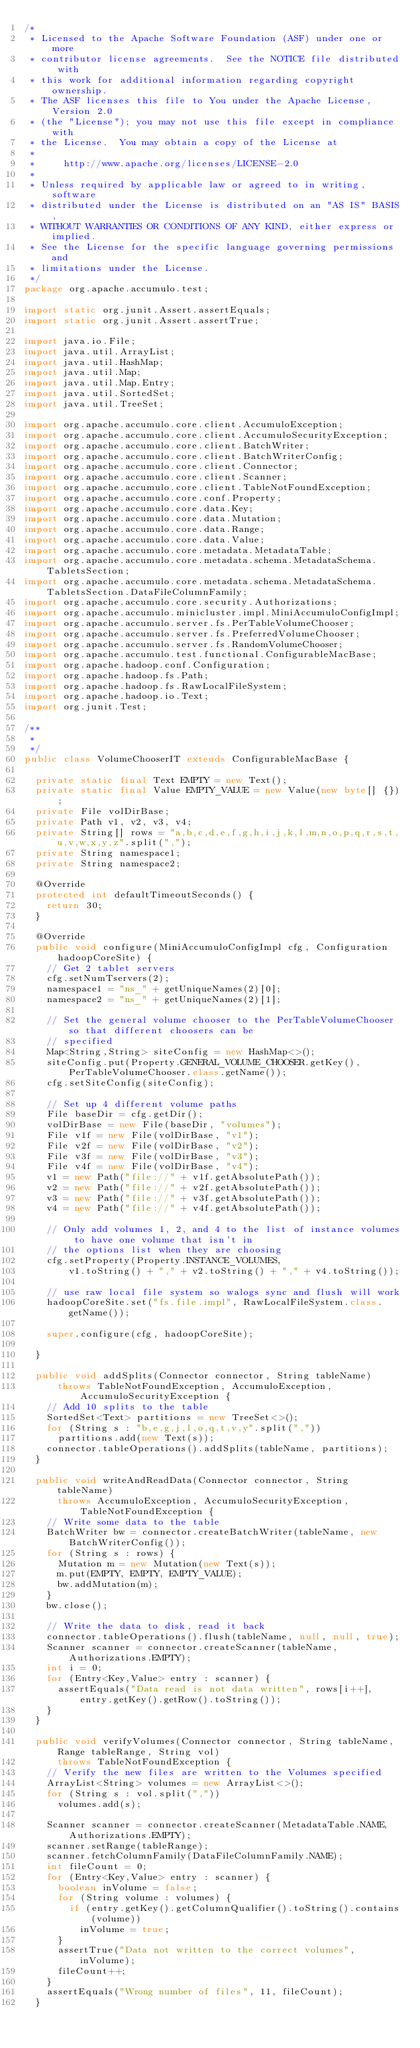<code> <loc_0><loc_0><loc_500><loc_500><_Java_>/*
 * Licensed to the Apache Software Foundation (ASF) under one or more
 * contributor license agreements.  See the NOTICE file distributed with
 * this work for additional information regarding copyright ownership.
 * The ASF licenses this file to You under the Apache License, Version 2.0
 * (the "License"); you may not use this file except in compliance with
 * the License.  You may obtain a copy of the License at
 *
 *     http://www.apache.org/licenses/LICENSE-2.0
 *
 * Unless required by applicable law or agreed to in writing, software
 * distributed under the License is distributed on an "AS IS" BASIS,
 * WITHOUT WARRANTIES OR CONDITIONS OF ANY KIND, either express or implied.
 * See the License for the specific language governing permissions and
 * limitations under the License.
 */
package org.apache.accumulo.test;

import static org.junit.Assert.assertEquals;
import static org.junit.Assert.assertTrue;

import java.io.File;
import java.util.ArrayList;
import java.util.HashMap;
import java.util.Map;
import java.util.Map.Entry;
import java.util.SortedSet;
import java.util.TreeSet;

import org.apache.accumulo.core.client.AccumuloException;
import org.apache.accumulo.core.client.AccumuloSecurityException;
import org.apache.accumulo.core.client.BatchWriter;
import org.apache.accumulo.core.client.BatchWriterConfig;
import org.apache.accumulo.core.client.Connector;
import org.apache.accumulo.core.client.Scanner;
import org.apache.accumulo.core.client.TableNotFoundException;
import org.apache.accumulo.core.conf.Property;
import org.apache.accumulo.core.data.Key;
import org.apache.accumulo.core.data.Mutation;
import org.apache.accumulo.core.data.Range;
import org.apache.accumulo.core.data.Value;
import org.apache.accumulo.core.metadata.MetadataTable;
import org.apache.accumulo.core.metadata.schema.MetadataSchema.TabletsSection;
import org.apache.accumulo.core.metadata.schema.MetadataSchema.TabletsSection.DataFileColumnFamily;
import org.apache.accumulo.core.security.Authorizations;
import org.apache.accumulo.minicluster.impl.MiniAccumuloConfigImpl;
import org.apache.accumulo.server.fs.PerTableVolumeChooser;
import org.apache.accumulo.server.fs.PreferredVolumeChooser;
import org.apache.accumulo.server.fs.RandomVolumeChooser;
import org.apache.accumulo.test.functional.ConfigurableMacBase;
import org.apache.hadoop.conf.Configuration;
import org.apache.hadoop.fs.Path;
import org.apache.hadoop.fs.RawLocalFileSystem;
import org.apache.hadoop.io.Text;
import org.junit.Test;

/**
 *
 */
public class VolumeChooserIT extends ConfigurableMacBase {

  private static final Text EMPTY = new Text();
  private static final Value EMPTY_VALUE = new Value(new byte[] {});
  private File volDirBase;
  private Path v1, v2, v3, v4;
  private String[] rows = "a,b,c,d,e,f,g,h,i,j,k,l,m,n,o,p,q,r,s,t,u,v,w,x,y,z".split(",");
  private String namespace1;
  private String namespace2;

  @Override
  protected int defaultTimeoutSeconds() {
    return 30;
  }

  @Override
  public void configure(MiniAccumuloConfigImpl cfg, Configuration hadoopCoreSite) {
    // Get 2 tablet servers
    cfg.setNumTservers(2);
    namespace1 = "ns_" + getUniqueNames(2)[0];
    namespace2 = "ns_" + getUniqueNames(2)[1];

    // Set the general volume chooser to the PerTableVolumeChooser so that different choosers can be
    // specified
    Map<String,String> siteConfig = new HashMap<>();
    siteConfig.put(Property.GENERAL_VOLUME_CHOOSER.getKey(), PerTableVolumeChooser.class.getName());
    cfg.setSiteConfig(siteConfig);

    // Set up 4 different volume paths
    File baseDir = cfg.getDir();
    volDirBase = new File(baseDir, "volumes");
    File v1f = new File(volDirBase, "v1");
    File v2f = new File(volDirBase, "v2");
    File v3f = new File(volDirBase, "v3");
    File v4f = new File(volDirBase, "v4");
    v1 = new Path("file://" + v1f.getAbsolutePath());
    v2 = new Path("file://" + v2f.getAbsolutePath());
    v3 = new Path("file://" + v3f.getAbsolutePath());
    v4 = new Path("file://" + v4f.getAbsolutePath());

    // Only add volumes 1, 2, and 4 to the list of instance volumes to have one volume that isn't in
    // the options list when they are choosing
    cfg.setProperty(Property.INSTANCE_VOLUMES,
        v1.toString() + "," + v2.toString() + "," + v4.toString());

    // use raw local file system so walogs sync and flush will work
    hadoopCoreSite.set("fs.file.impl", RawLocalFileSystem.class.getName());

    super.configure(cfg, hadoopCoreSite);

  }

  public void addSplits(Connector connector, String tableName)
      throws TableNotFoundException, AccumuloException, AccumuloSecurityException {
    // Add 10 splits to the table
    SortedSet<Text> partitions = new TreeSet<>();
    for (String s : "b,e,g,j,l,o,q,t,v,y".split(","))
      partitions.add(new Text(s));
    connector.tableOperations().addSplits(tableName, partitions);
  }

  public void writeAndReadData(Connector connector, String tableName)
      throws AccumuloException, AccumuloSecurityException, TableNotFoundException {
    // Write some data to the table
    BatchWriter bw = connector.createBatchWriter(tableName, new BatchWriterConfig());
    for (String s : rows) {
      Mutation m = new Mutation(new Text(s));
      m.put(EMPTY, EMPTY, EMPTY_VALUE);
      bw.addMutation(m);
    }
    bw.close();

    // Write the data to disk, read it back
    connector.tableOperations().flush(tableName, null, null, true);
    Scanner scanner = connector.createScanner(tableName, Authorizations.EMPTY);
    int i = 0;
    for (Entry<Key,Value> entry : scanner) {
      assertEquals("Data read is not data written", rows[i++], entry.getKey().getRow().toString());
    }
  }

  public void verifyVolumes(Connector connector, String tableName, Range tableRange, String vol)
      throws TableNotFoundException {
    // Verify the new files are written to the Volumes specified
    ArrayList<String> volumes = new ArrayList<>();
    for (String s : vol.split(","))
      volumes.add(s);

    Scanner scanner = connector.createScanner(MetadataTable.NAME, Authorizations.EMPTY);
    scanner.setRange(tableRange);
    scanner.fetchColumnFamily(DataFileColumnFamily.NAME);
    int fileCount = 0;
    for (Entry<Key,Value> entry : scanner) {
      boolean inVolume = false;
      for (String volume : volumes) {
        if (entry.getKey().getColumnQualifier().toString().contains(volume))
          inVolume = true;
      }
      assertTrue("Data not written to the correct volumes", inVolume);
      fileCount++;
    }
    assertEquals("Wrong number of files", 11, fileCount);
  }
</code> 